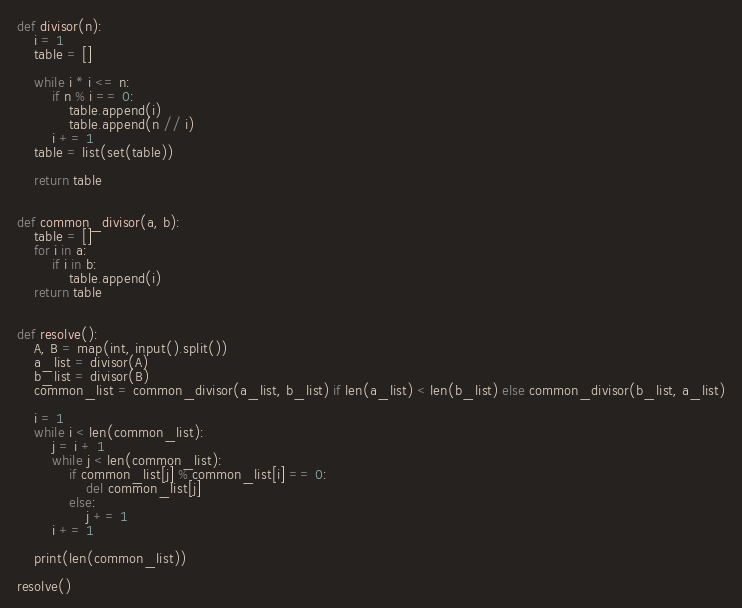Convert code to text. <code><loc_0><loc_0><loc_500><loc_500><_Python_>def divisor(n):
    i = 1
    table = []

    while i * i <= n:
        if n % i == 0:
            table.append(i)
            table.append(n // i)
        i += 1
    table = list(set(table))

    return table


def common_divisor(a, b):
    table = []
    for i in a:
        if i in b:
            table.append(i)
    return table


def resolve():
    A, B = map(int, input().split())
    a_list = divisor(A)
    b_list = divisor(B)
    common_list = common_divisor(a_list, b_list) if len(a_list) < len(b_list) else common_divisor(b_list, a_list)

    i = 1
    while i < len(common_list):
        j = i + 1
        while j < len(common_list):
            if common_list[j] % common_list[i] == 0:
                del common_list[j]
            else:
                j += 1
        i += 1

    print(len(common_list))
    
resolve()
</code> 